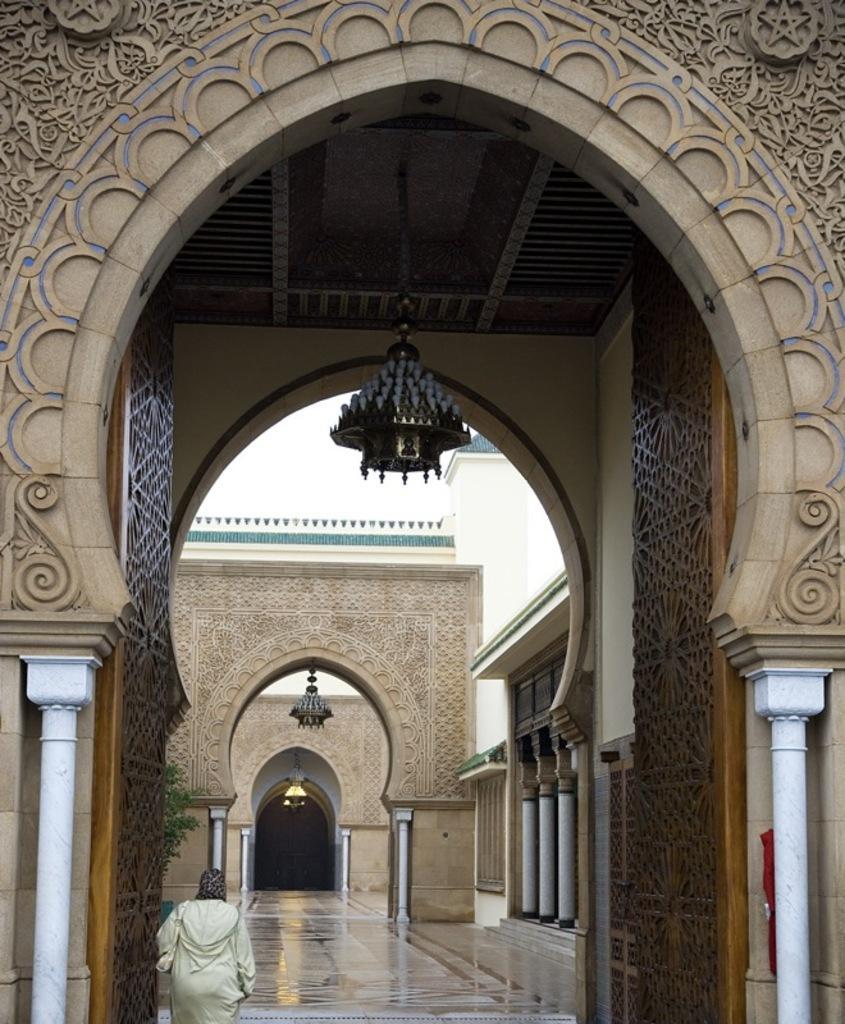How would you summarize this image in a sentence or two? This image is taken indoors. In this image there is an architecture with walls, pillars, doors and there are many carvings on the walls. At the top of the image there is a roof. There is an antique lamp. On the left side of the image a person is standing on the floor. 